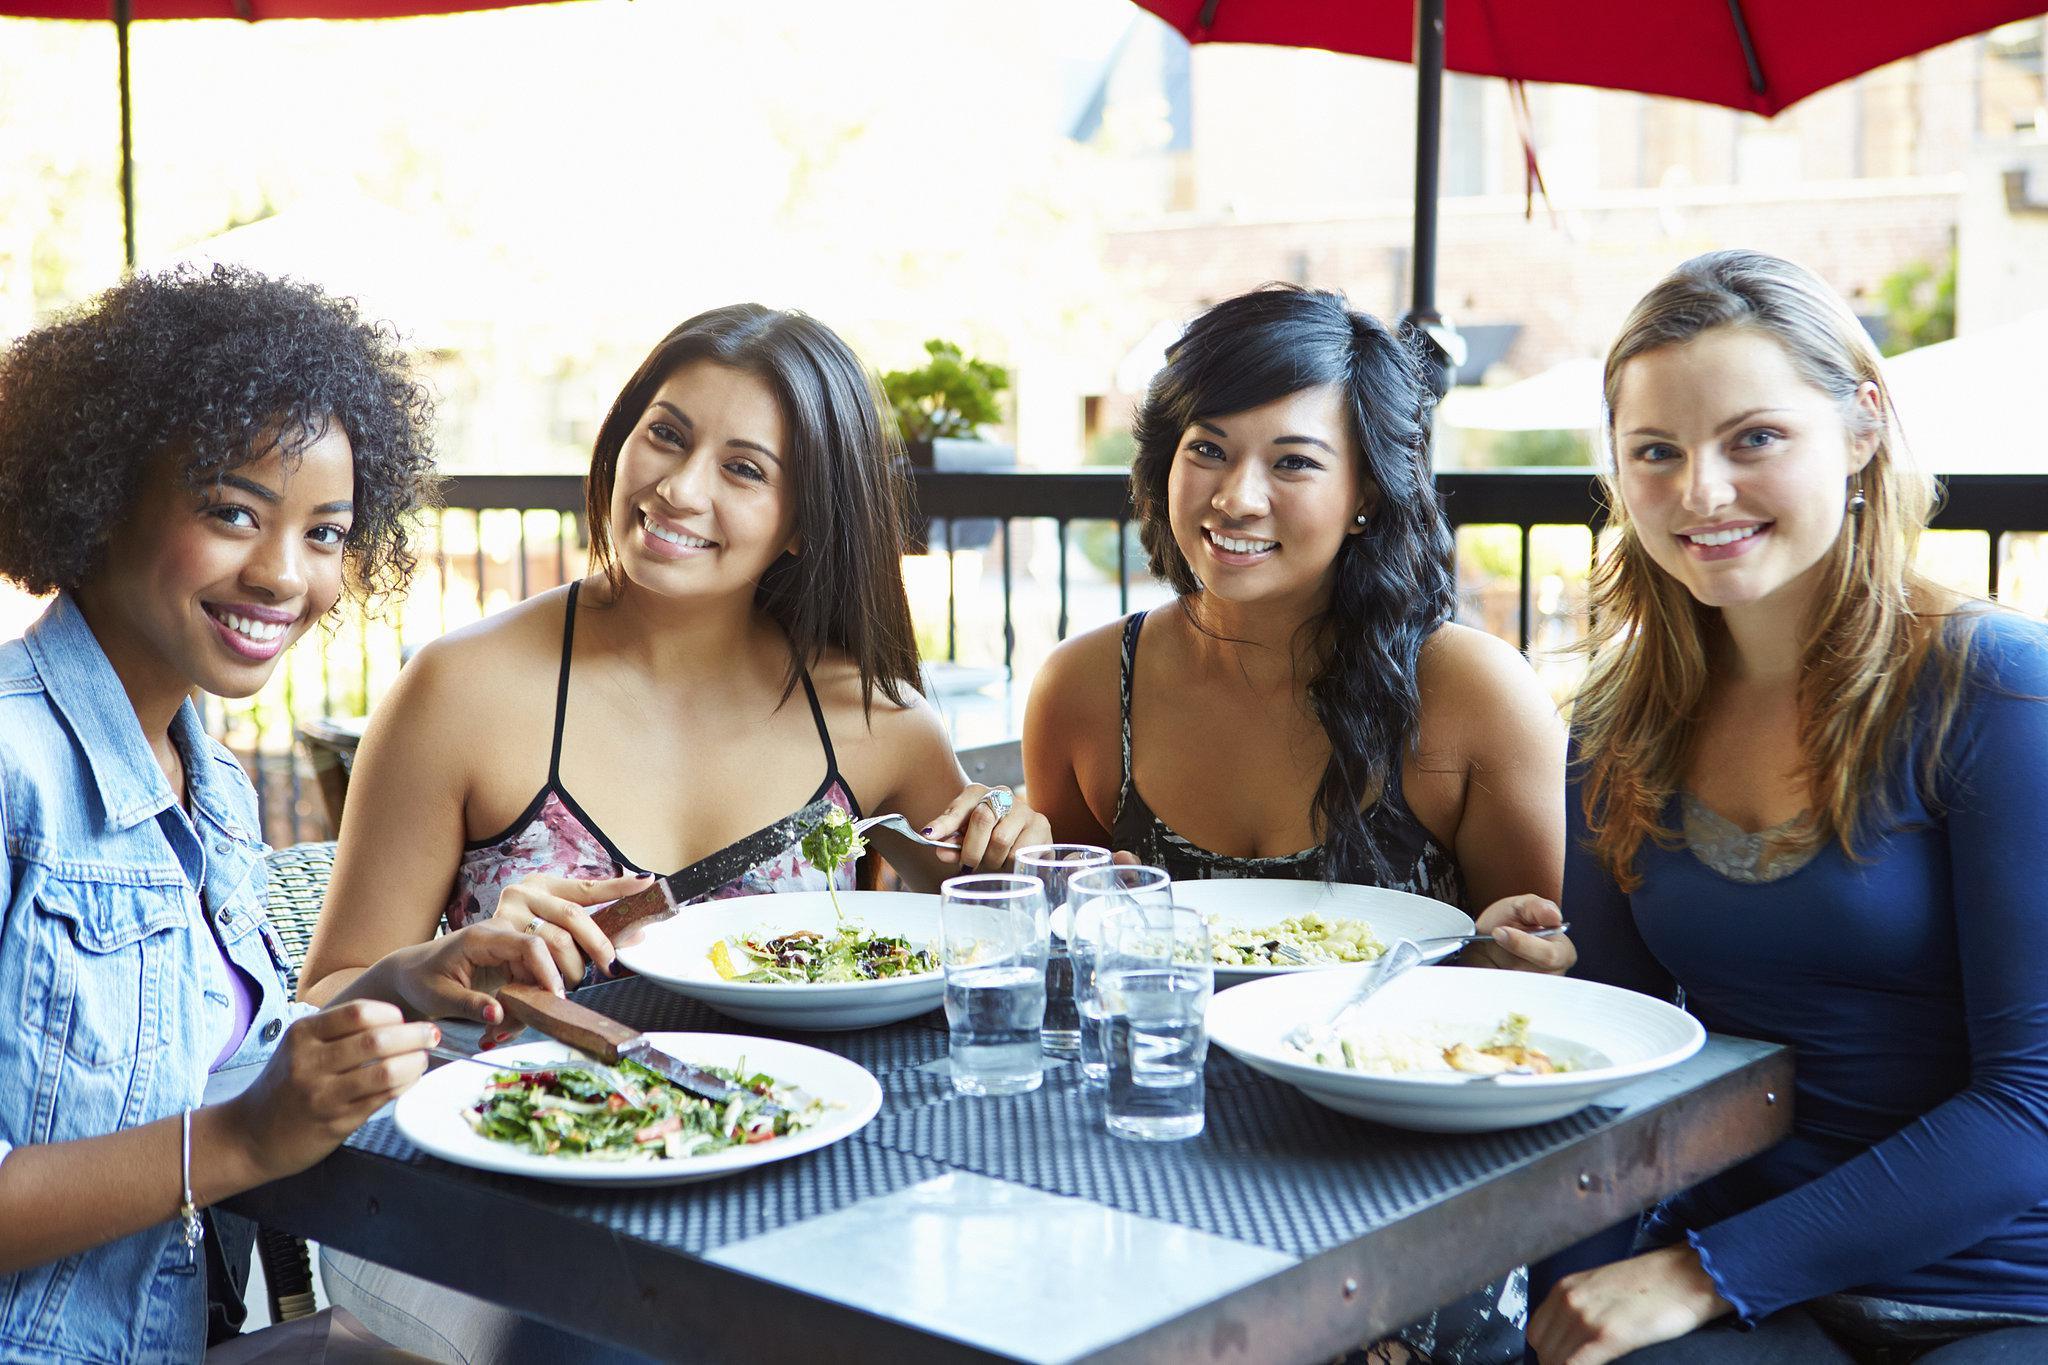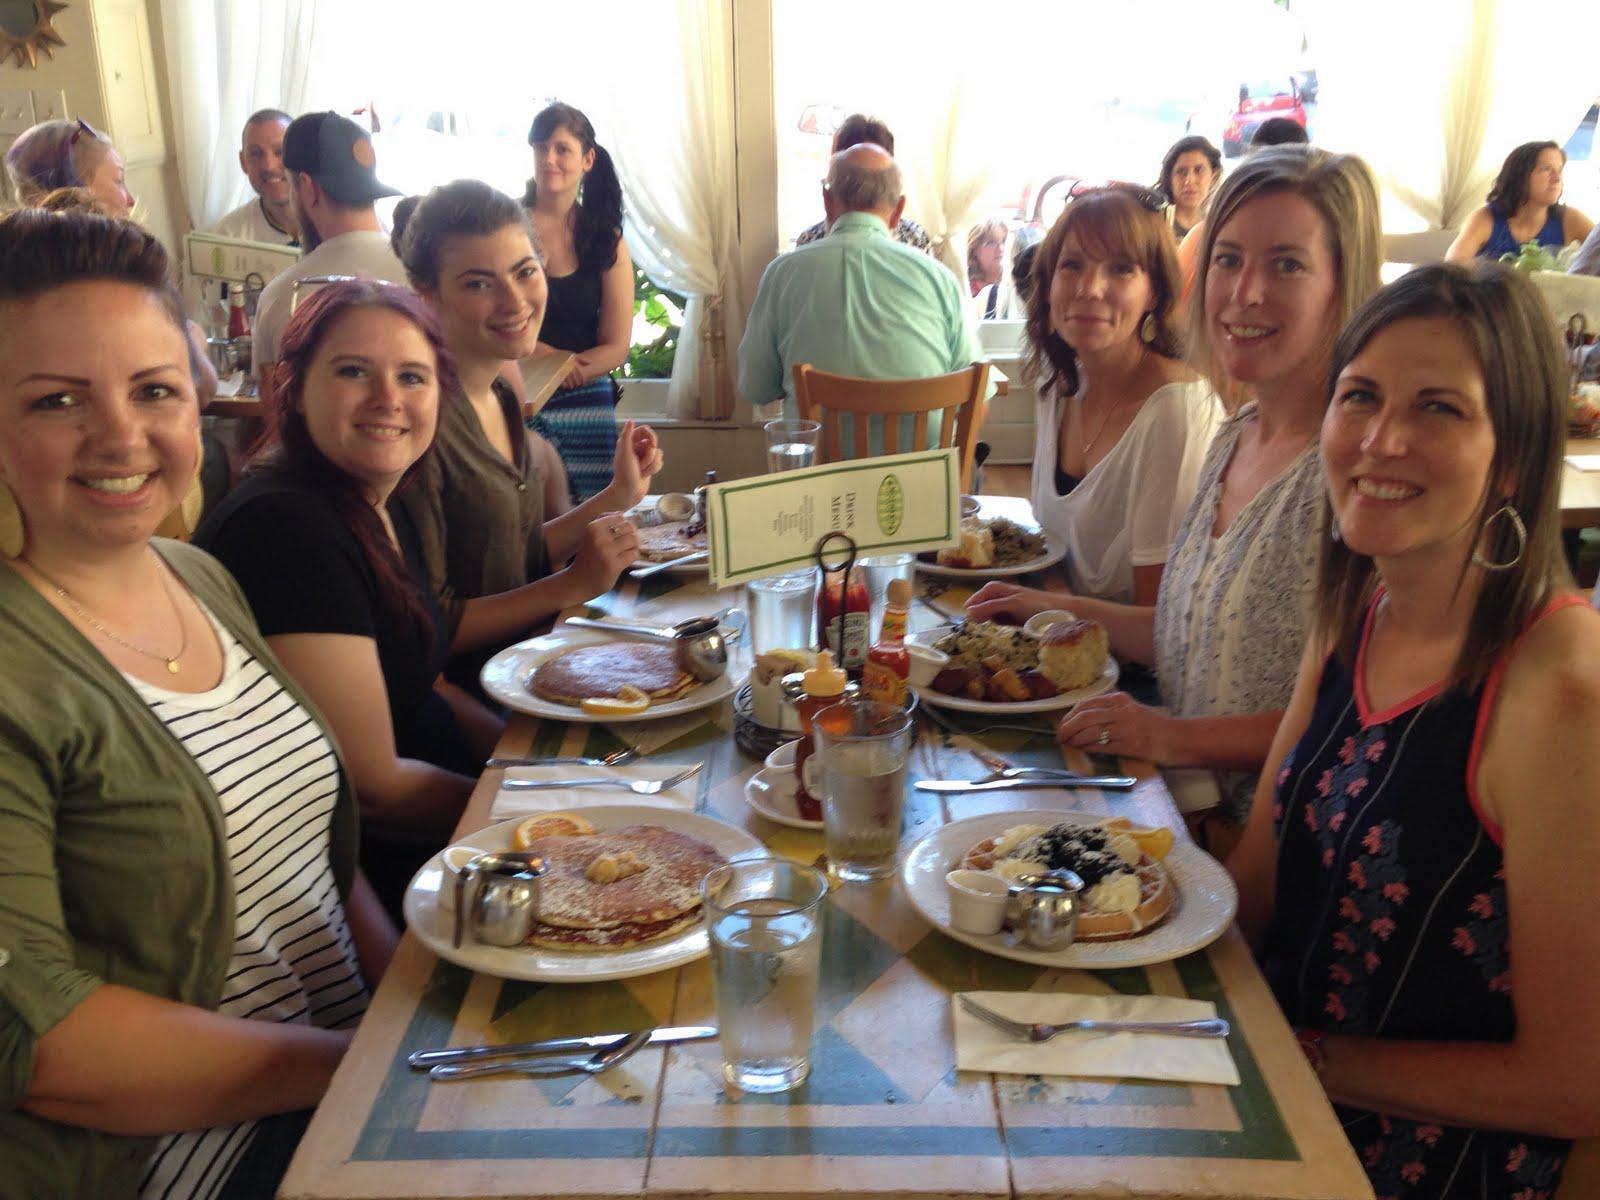The first image is the image on the left, the second image is the image on the right. Examine the images to the left and right. Is the description "The people around the tables are looking at each other and not the camera." accurate? Answer yes or no. No. 